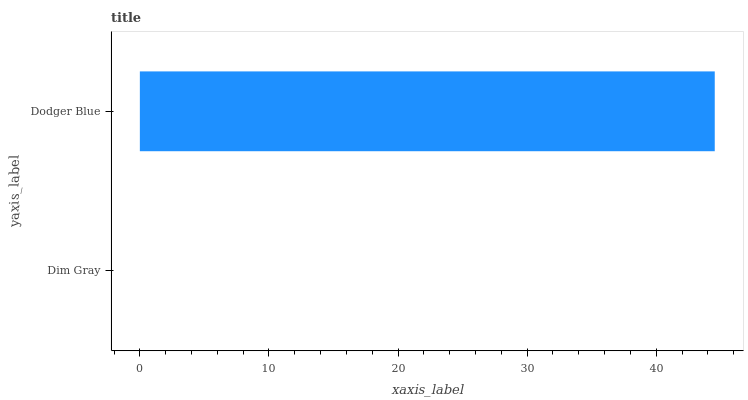Is Dim Gray the minimum?
Answer yes or no. Yes. Is Dodger Blue the maximum?
Answer yes or no. Yes. Is Dodger Blue the minimum?
Answer yes or no. No. Is Dodger Blue greater than Dim Gray?
Answer yes or no. Yes. Is Dim Gray less than Dodger Blue?
Answer yes or no. Yes. Is Dim Gray greater than Dodger Blue?
Answer yes or no. No. Is Dodger Blue less than Dim Gray?
Answer yes or no. No. Is Dodger Blue the high median?
Answer yes or no. Yes. Is Dim Gray the low median?
Answer yes or no. Yes. Is Dim Gray the high median?
Answer yes or no. No. Is Dodger Blue the low median?
Answer yes or no. No. 